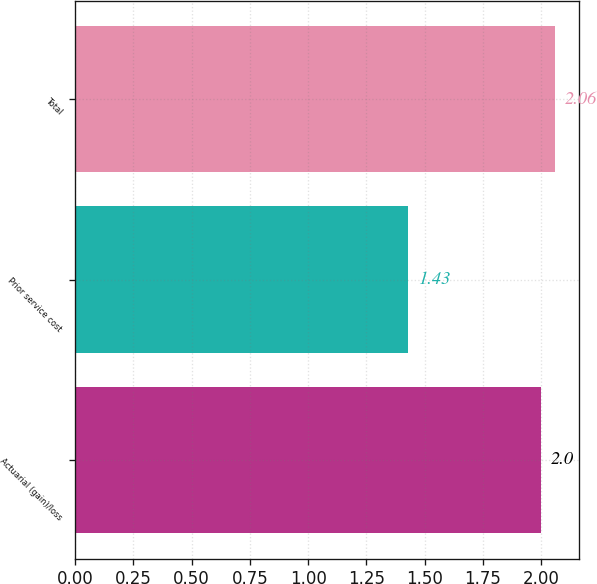Convert chart to OTSL. <chart><loc_0><loc_0><loc_500><loc_500><bar_chart><fcel>Actuarial (gain)/loss<fcel>Prior service cost<fcel>Total<nl><fcel>2<fcel>1.43<fcel>2.06<nl></chart> 